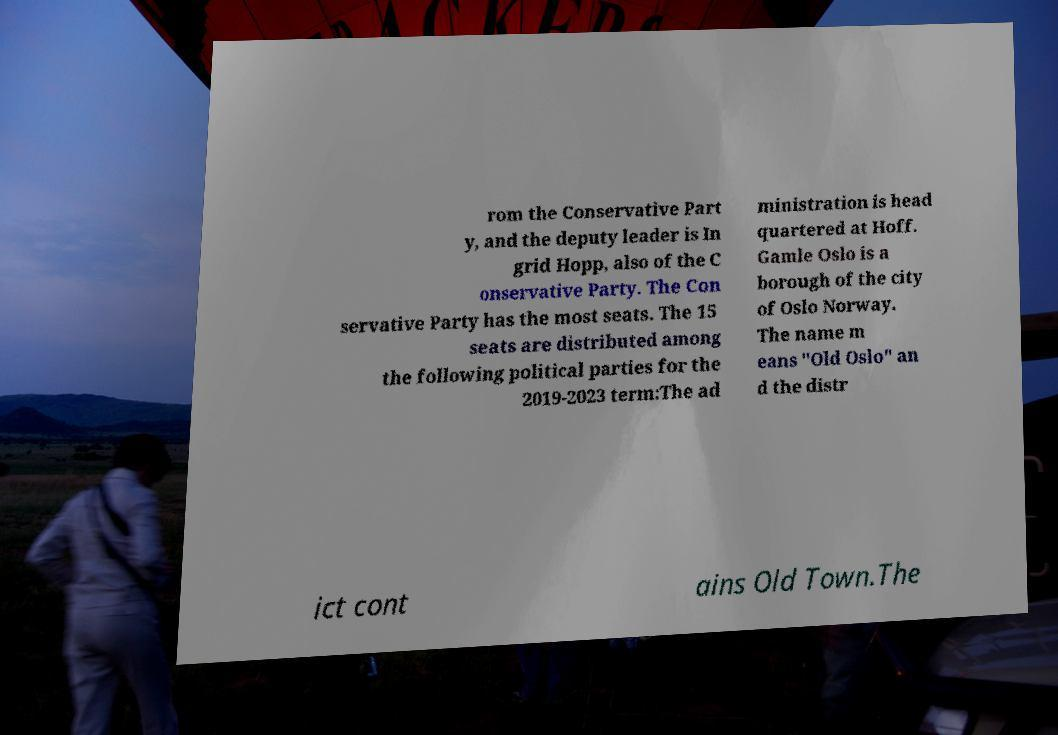There's text embedded in this image that I need extracted. Can you transcribe it verbatim? rom the Conservative Part y, and the deputy leader is In grid Hopp, also of the C onservative Party. The Con servative Party has the most seats. The 15 seats are distributed among the following political parties for the 2019-2023 term:The ad ministration is head quartered at Hoff. Gamle Oslo is a borough of the city of Oslo Norway. The name m eans "Old Oslo" an d the distr ict cont ains Old Town.The 